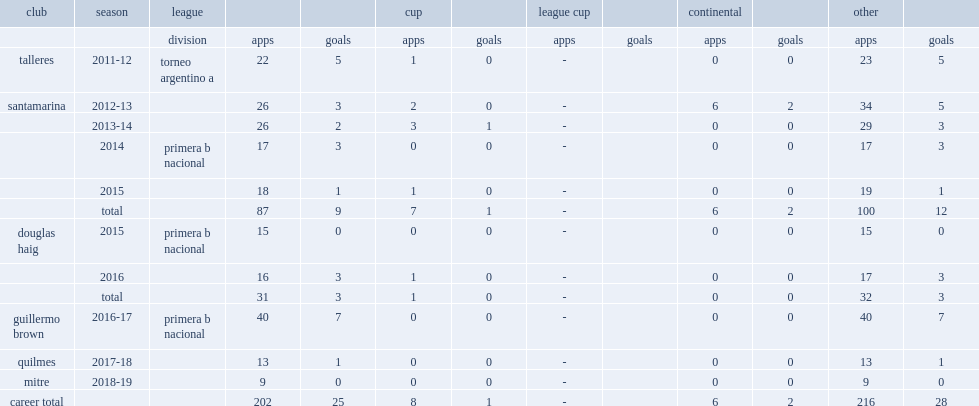Which league did roman strada appear with guillermo brown in 2016-17, quilmes in 2017-18, and mitre in 2018? Primera b nacional. 